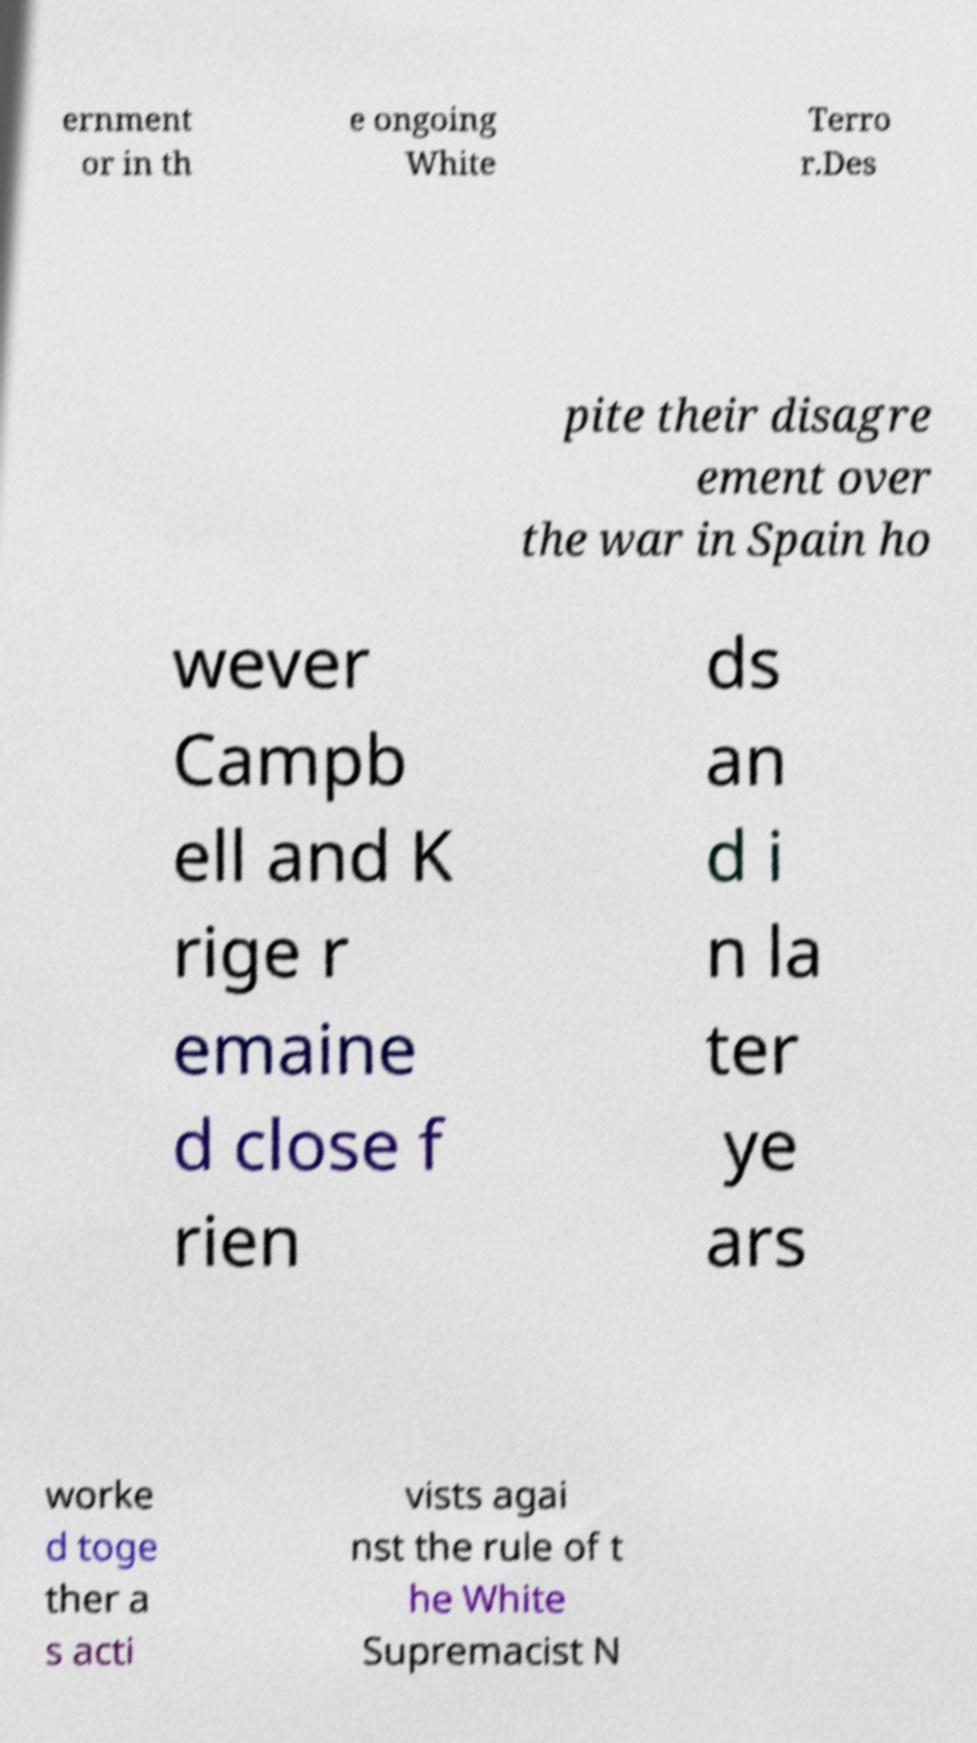What messages or text are displayed in this image? I need them in a readable, typed format. ernment or in th e ongoing White Terro r.Des pite their disagre ement over the war in Spain ho wever Campb ell and K rige r emaine d close f rien ds an d i n la ter ye ars worke d toge ther a s acti vists agai nst the rule of t he White Supremacist N 